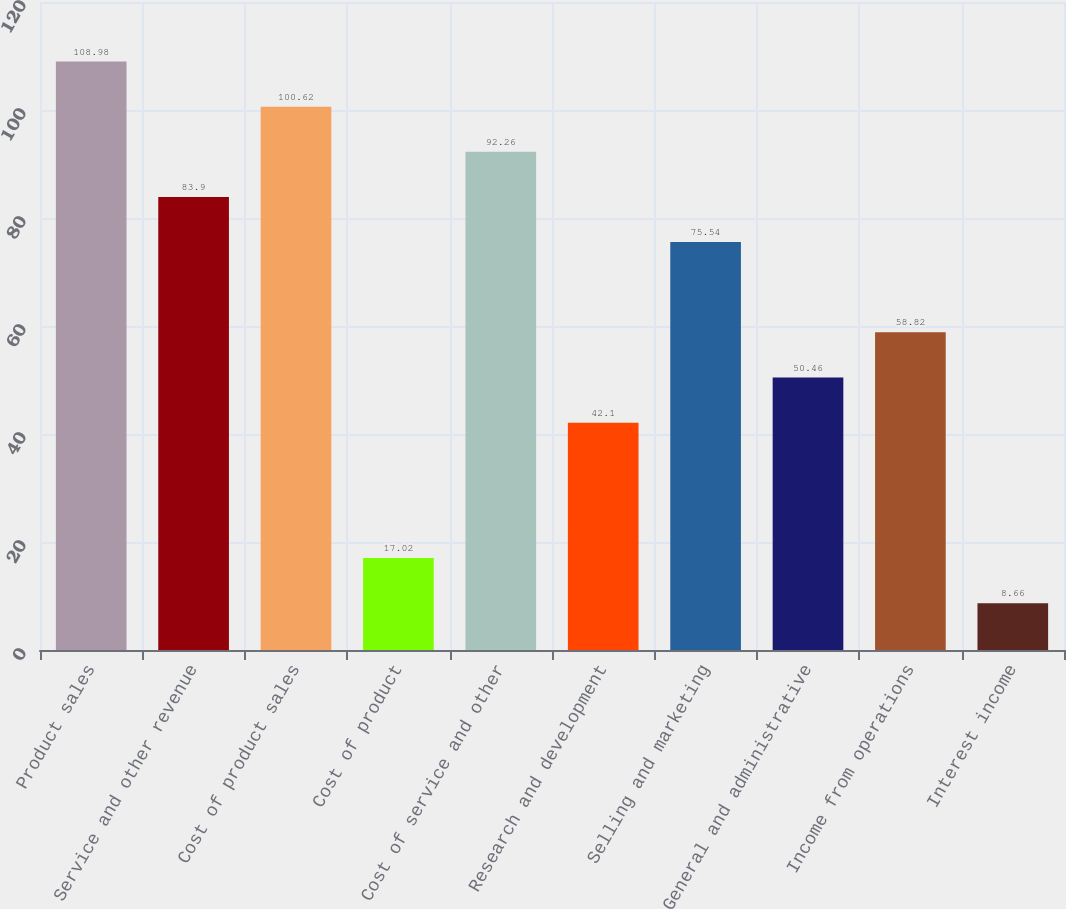Convert chart to OTSL. <chart><loc_0><loc_0><loc_500><loc_500><bar_chart><fcel>Product sales<fcel>Service and other revenue<fcel>Cost of product sales<fcel>Cost of product<fcel>Cost of service and other<fcel>Research and development<fcel>Selling and marketing<fcel>General and administrative<fcel>Income from operations<fcel>Interest income<nl><fcel>108.98<fcel>83.9<fcel>100.62<fcel>17.02<fcel>92.26<fcel>42.1<fcel>75.54<fcel>50.46<fcel>58.82<fcel>8.66<nl></chart> 